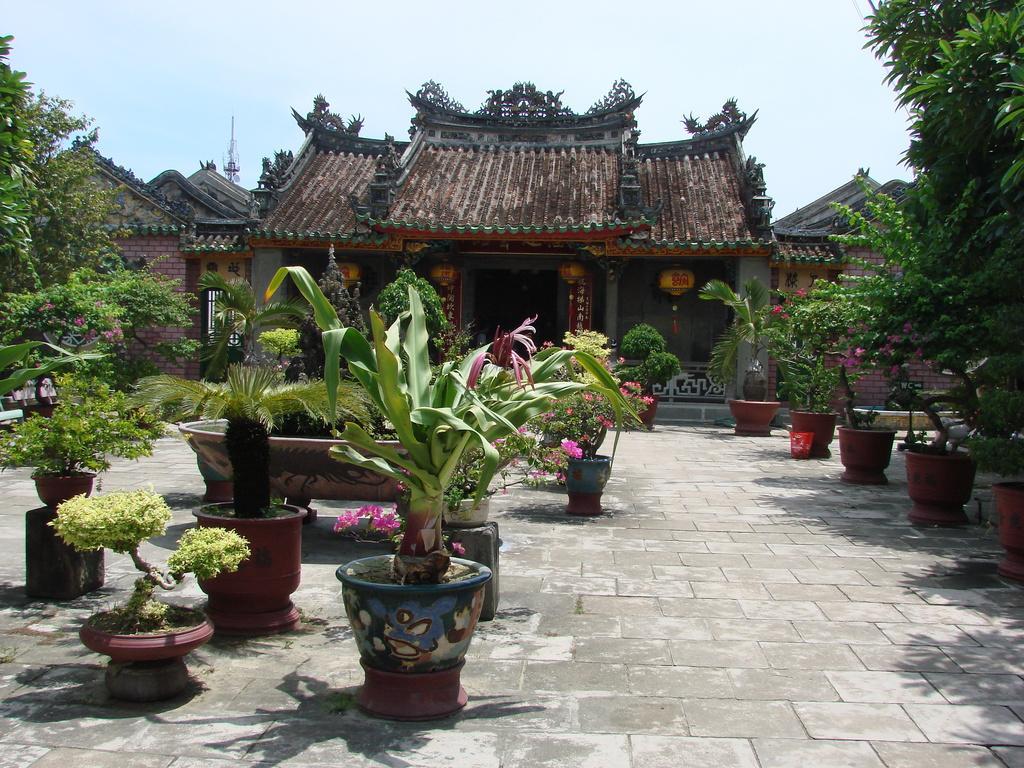Describe this image in one or two sentences. In this image we can see a house, in front the house there are some house plants and trees, also we can see some trees and a pole, in the background we can see the sky. 